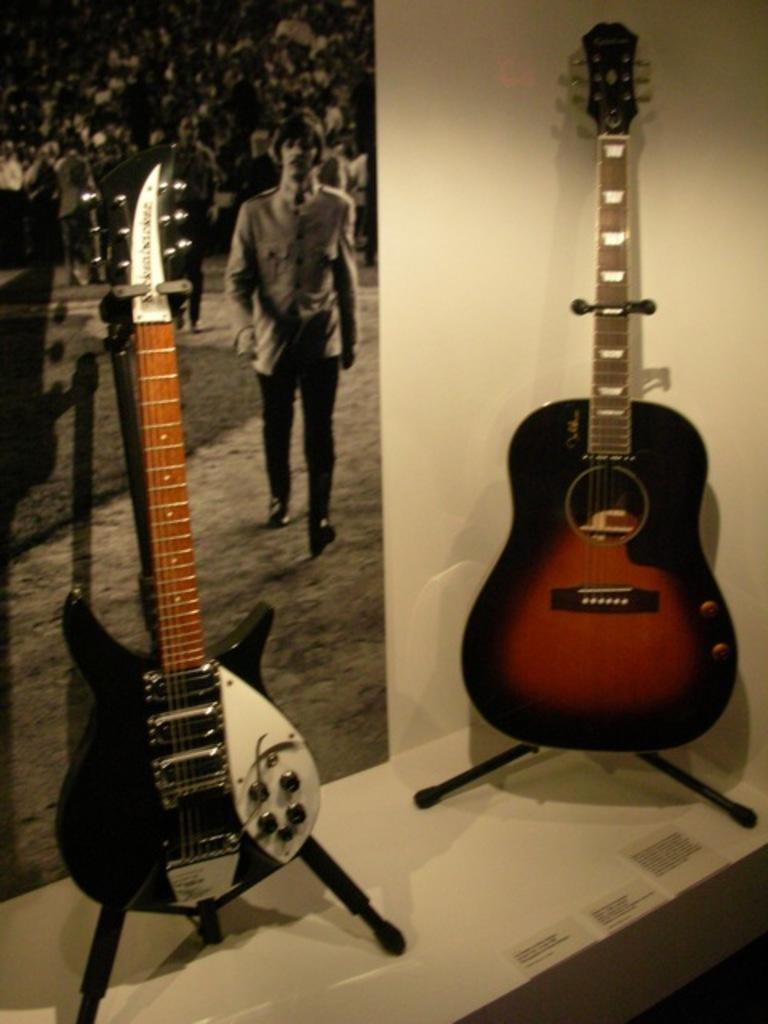What musical instruments are present in the image? There are two guitars in the image. What is the person in the image doing? The person is walking in the image. How are the majority of people in the image positioned? There is a crowd sitting in the image. What type of popcorn is being served at the hospital in the image? There is no mention of popcorn or a hospital in the image; it features two guitars, a person walking, and a crowd sitting. 